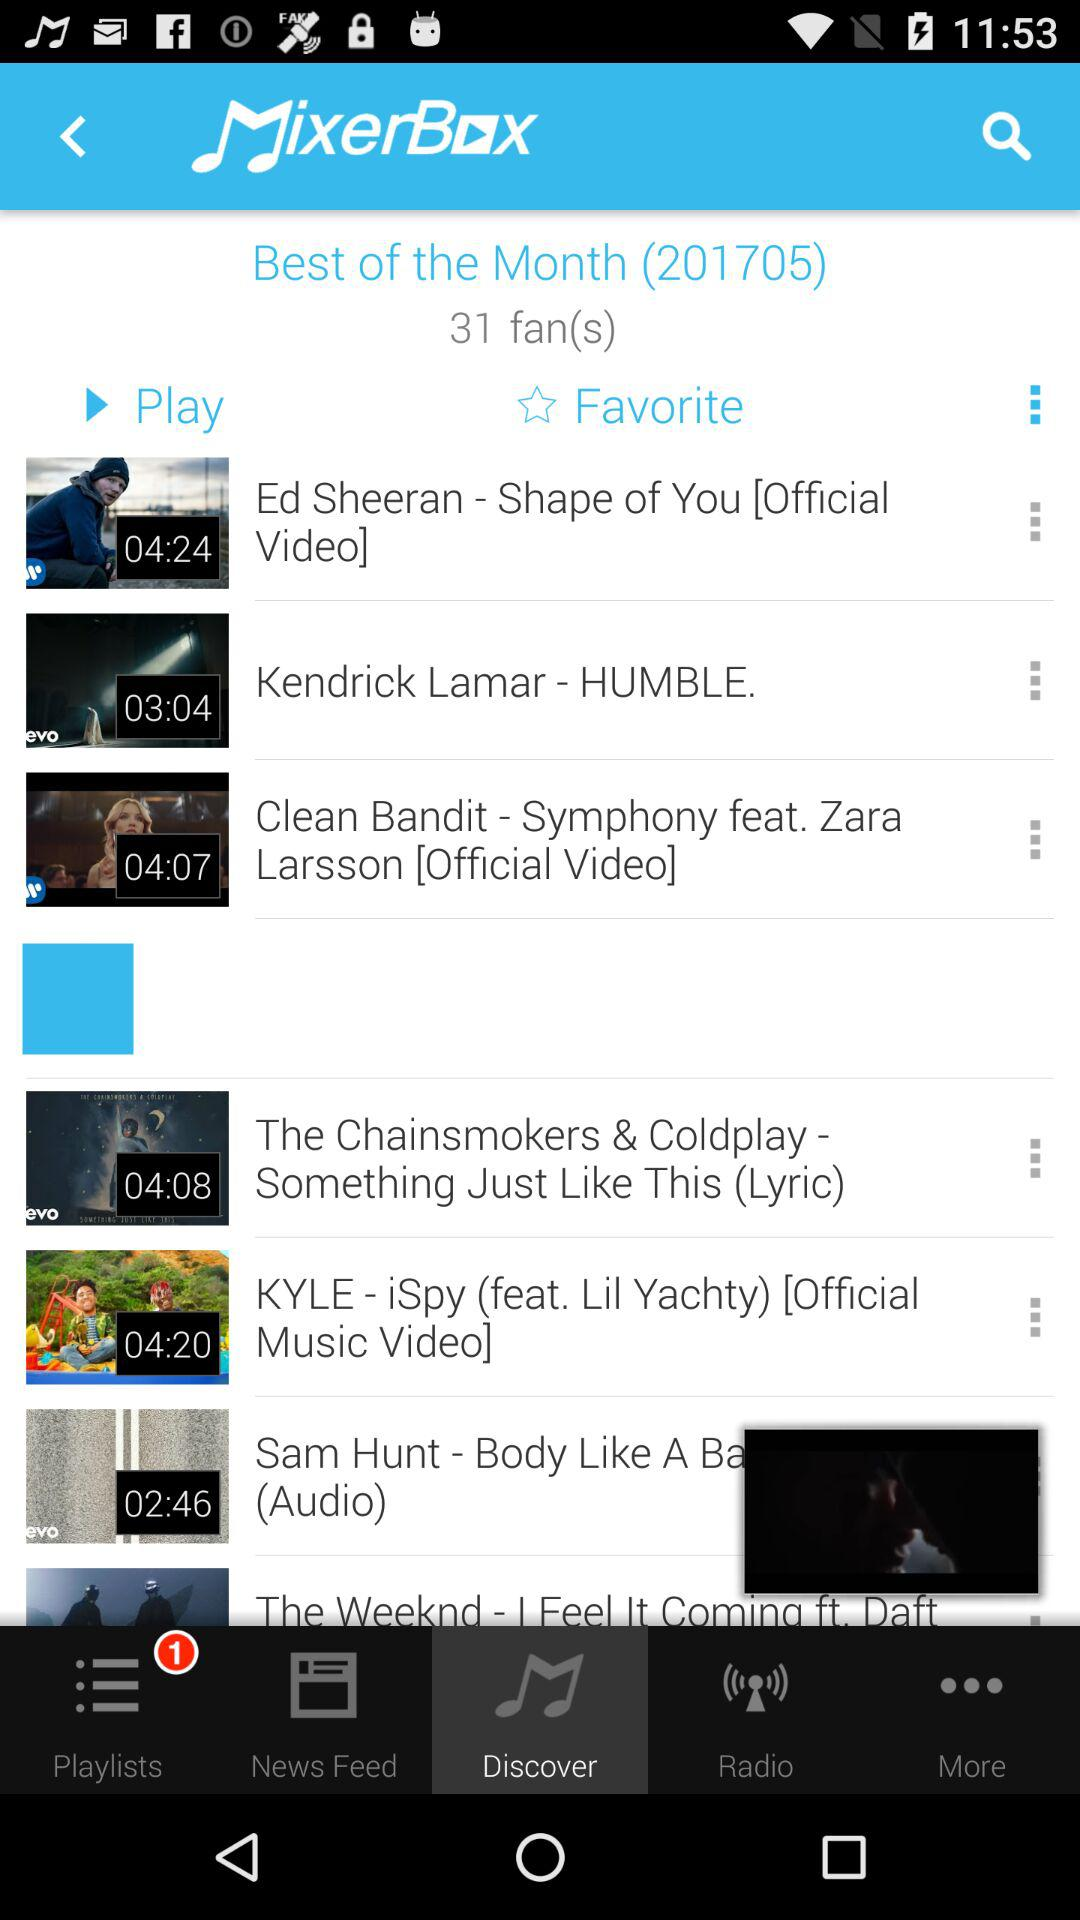What is the total number of the best songs of the month?
When the provided information is insufficient, respond with <no answer>. <no answer> 